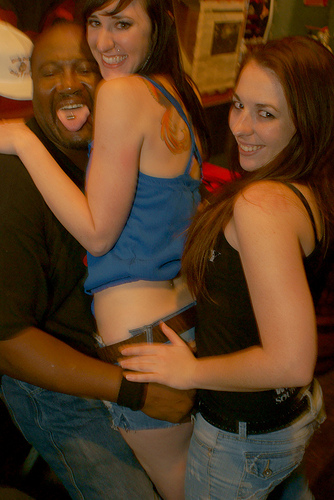<image>
Can you confirm if the girl is on the man? Yes. Looking at the image, I can see the girl is positioned on top of the man, with the man providing support. Where is the girl in relation to the man? Is it on the man? No. The girl is not positioned on the man. They may be near each other, but the girl is not supported by or resting on top of the man. Is the hat behind the woman? Yes. From this viewpoint, the hat is positioned behind the woman, with the woman partially or fully occluding the hat. 